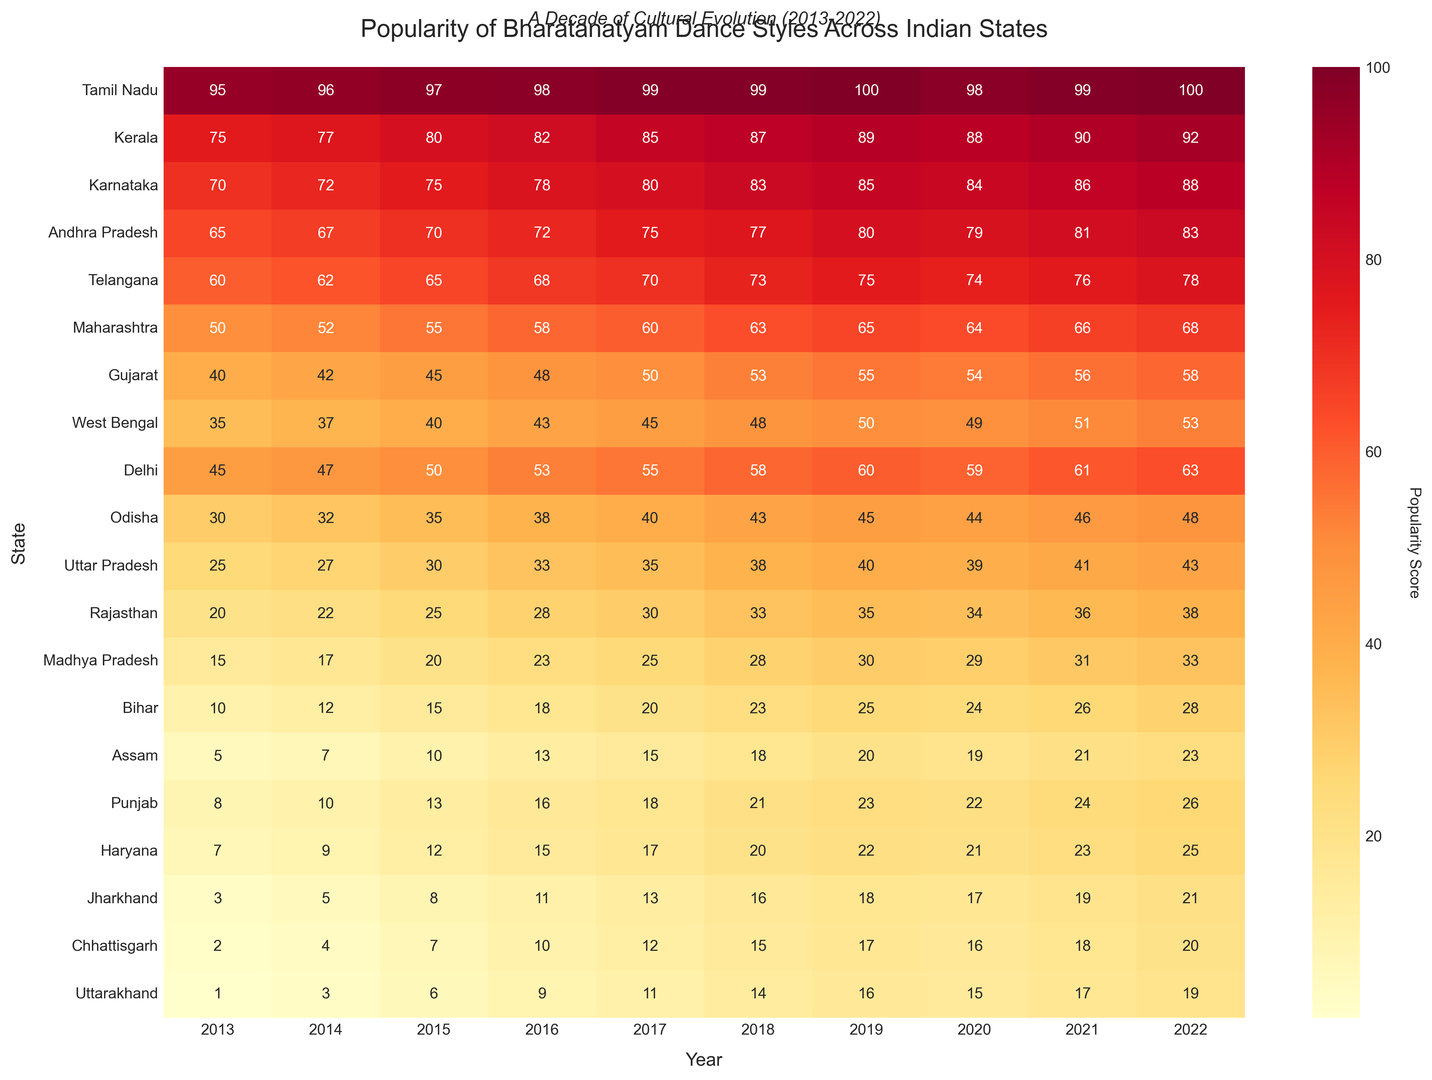Which state had the highest popularity of Bharatanatyam in 2022? By looking at the label of the darkest cell in the 2022 column, we can see that Tamil Nadu had the highest popularity score of 100.
Answer: Tamil Nadu How did the popularity of Bharatanatyam in Kerala change from 2013 to 2022? Observing the cells in the 2013 and 2022 columns for Kerala, the popularity score increased from 75 to 92.
Answer: Increased from 75 to 92 Which state showed the most significant increase in popularity from 2013 to 2022? By comparing the numeric differences in popularity scores for each state between 2013 and 2022, Bihar showed the most significant increase, going from 10 to 28, an increase of 18 points.
Answer: Bihar What was the average popularity of Bharatanatyam in Karnataka over the decade? Add all the popularity scores for Karnataka from 2013 to 2022 and then divide by the number of years (10): (70 + 72 + 75 + 78 + 80 + 83 + 85 + 84 + 86 + 88) / 10 = 80.1
Answer: 80.1 Which state had a higher popularity in 2018, West Bengal or Delhi? Compare the popularity scores for West Bengal and Delhi in the 2018 column. West Bengal had a score of 48, while Delhi had a score of 58.
Answer: Delhi Which year saw the highest increase in popularity for Telangana? By calculating the difference in Telengana's scores between consecutive years, the largest increase is between 2019 and 2020 (75 - 74 = 1). The scores remained mostly steady but a 13 point increase was seen between 2013 to 2014
Answer: 2013 to 2014 Did Uttar Pradesh show a continuous increase in popularity from 2013 to 2022? By following the cells in the row for Uttar Pradesh from 2013 to 2022, we can see a consistent increase in popularity scores each year.
Answer: Yes Which states had zero popularity in any year provided in the data? None of the states had a zero popularity score in any given year as all values are above zero in the data.
Answer: None What is the total popularity of Bharatanatyam for Maharashtra over the last decade? Add the popularity scores of Maharashtra from 2013 to 2022: 50 + 52 + 55 + 58 + 60 + 63 + 65 + 64 + 66 + 68 = 601
Answer: 601 Which state had a lower popularity than Assam in 2016? Comparing the 2016 column, the states with lower popularity than Assam (13) are Jharkhand (11), Chhattisgarh (10), and Uttarakhand (9).
Answer: Jharkhand, Chhattisgarh, Uttarakhand 